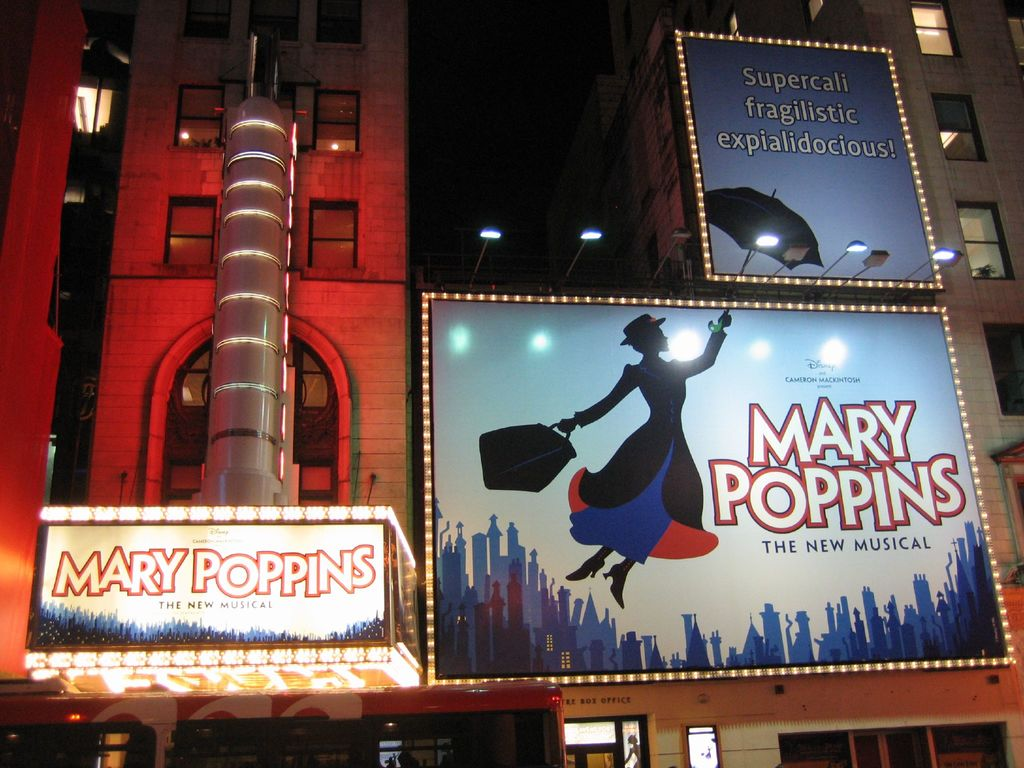Can you tell me more about the architectural design of the theater? The theater's architectural design combines traditional and modern elements. The building itself is clad in red brick, lending it a classic, timeless look. A distinctive silver cylindrical structure on the left side of the facade adds a contemporary touch. This combination symbolizes a bridge between the classic tales told within its walls and the modern interpretations they undergo, much like the story of Mary Poppins itself. 